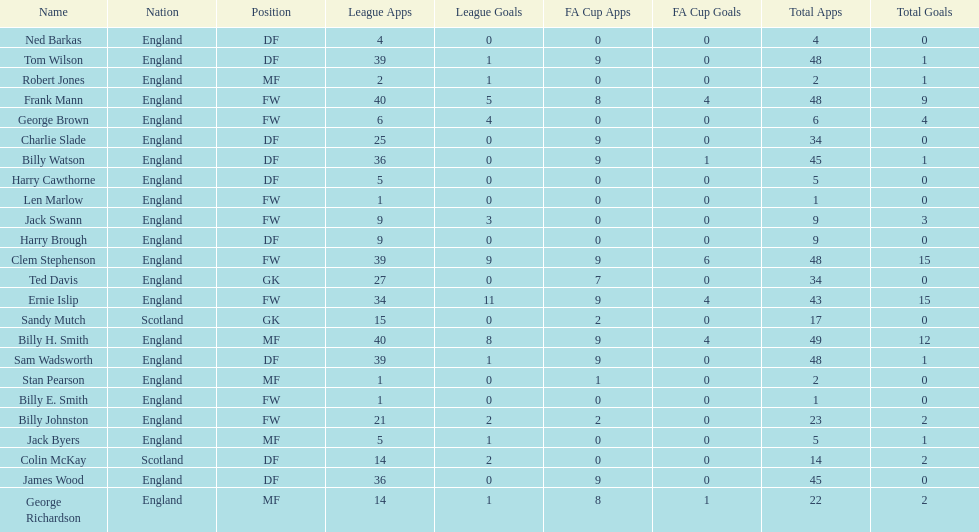Average number of goals scored by players from scotland 1. 